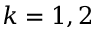Convert formula to latex. <formula><loc_0><loc_0><loc_500><loc_500>k = 1 , 2</formula> 